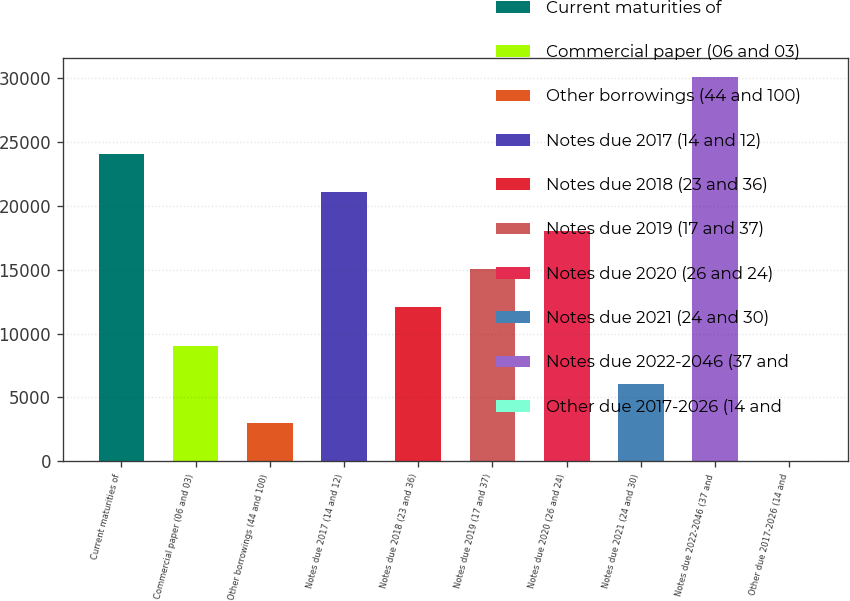<chart> <loc_0><loc_0><loc_500><loc_500><bar_chart><fcel>Current maturities of<fcel>Commercial paper (06 and 03)<fcel>Other borrowings (44 and 100)<fcel>Notes due 2017 (14 and 12)<fcel>Notes due 2018 (23 and 36)<fcel>Notes due 2019 (17 and 37)<fcel>Notes due 2020 (26 and 24)<fcel>Notes due 2021 (24 and 30)<fcel>Notes due 2022-2046 (37 and<fcel>Other due 2017-2026 (14 and<nl><fcel>24049.4<fcel>9040.4<fcel>3036.8<fcel>21047.6<fcel>12042.2<fcel>15044<fcel>18045.8<fcel>6038.6<fcel>30053<fcel>35<nl></chart> 